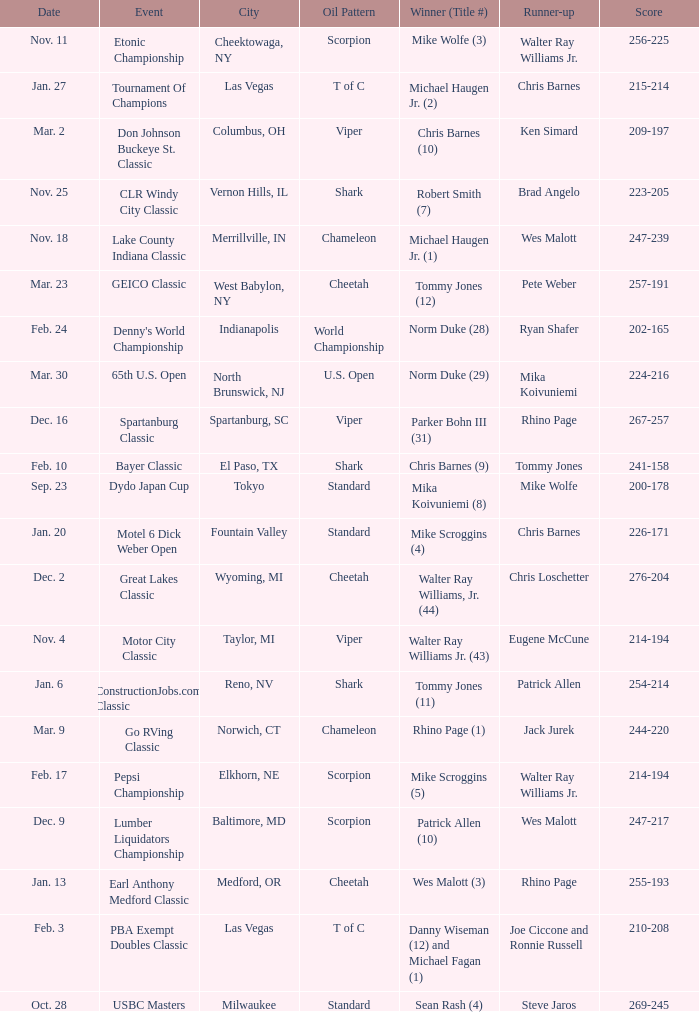Which Oil Pattern has a Winner (Title #) of mike wolfe (3)? Scorpion. 